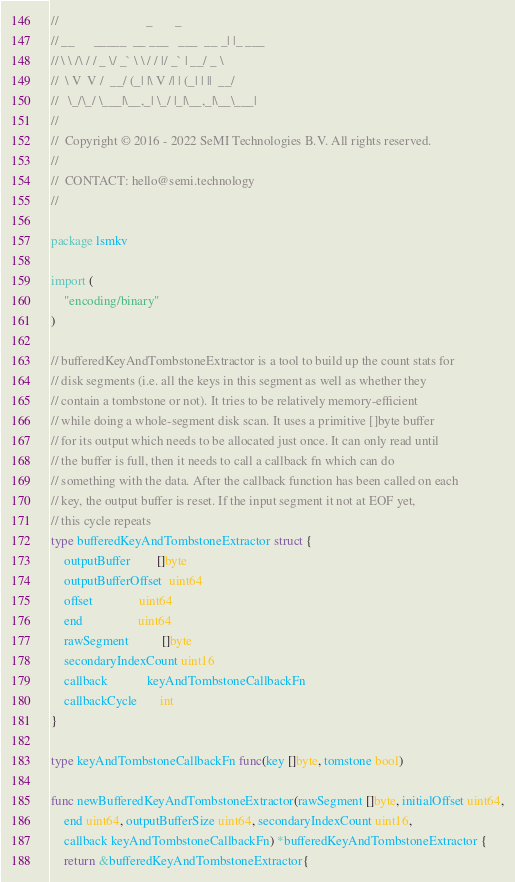Convert code to text. <code><loc_0><loc_0><loc_500><loc_500><_Go_>//                           _       _
// __      _____  __ ___   ___  __ _| |_ ___
// \ \ /\ / / _ \/ _` \ \ / / |/ _` | __/ _ \
//  \ V  V /  __/ (_| |\ V /| | (_| | ||  __/
//   \_/\_/ \___|\__,_| \_/ |_|\__,_|\__\___|
//
//  Copyright © 2016 - 2022 SeMI Technologies B.V. All rights reserved.
//
//  CONTACT: hello@semi.technology
//

package lsmkv

import (
	"encoding/binary"
)

// bufferedKeyAndTombstoneExtractor is a tool to build up the count stats for
// disk segments (i.e. all the keys in this segment as well as whether they
// contain a tombstone or not). It tries to be relatively memory-efficient
// while doing a whole-segment disk scan. It uses a primitive []byte buffer
// for its output which needs to be allocated just once. It can only read until
// the buffer is full, then it needs to call a callback fn which can do
// something with the data. After the callback function has been called on each
// key, the output buffer is reset. If the input segment it not at EOF yet,
// this cycle repeats
type bufferedKeyAndTombstoneExtractor struct {
	outputBuffer        []byte
	outputBufferOffset  uint64
	offset              uint64
	end                 uint64
	rawSegment          []byte
	secondaryIndexCount uint16
	callback            keyAndTombstoneCallbackFn
	callbackCycle       int
}

type keyAndTombstoneCallbackFn func(key []byte, tomstone bool)

func newBufferedKeyAndTombstoneExtractor(rawSegment []byte, initialOffset uint64,
	end uint64, outputBufferSize uint64, secondaryIndexCount uint16,
	callback keyAndTombstoneCallbackFn) *bufferedKeyAndTombstoneExtractor {
	return &bufferedKeyAndTombstoneExtractor{</code> 